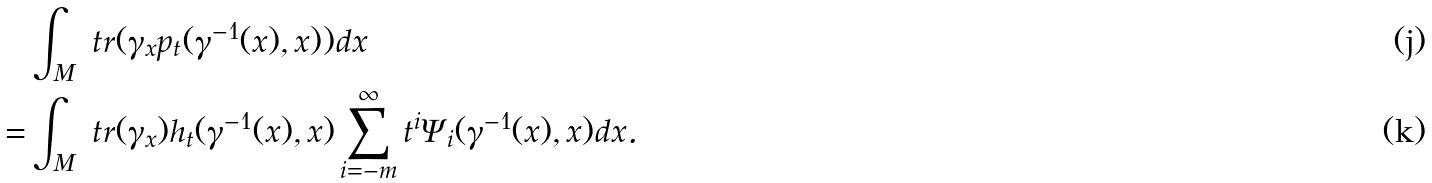Convert formula to latex. <formula><loc_0><loc_0><loc_500><loc_500>& \int _ { M } \ t r ( \gamma _ { x } p _ { t } ( \gamma ^ { - 1 } ( x ) , x ) ) d x \\ = & \int _ { M } \ t r ( \gamma _ { x } ) h _ { t } ( \gamma ^ { - 1 } ( x ) , x ) \sum _ { i = - m } ^ { \infty } t ^ { i } \Psi _ { i } ( \gamma ^ { - 1 } ( x ) , x ) d x .</formula> 